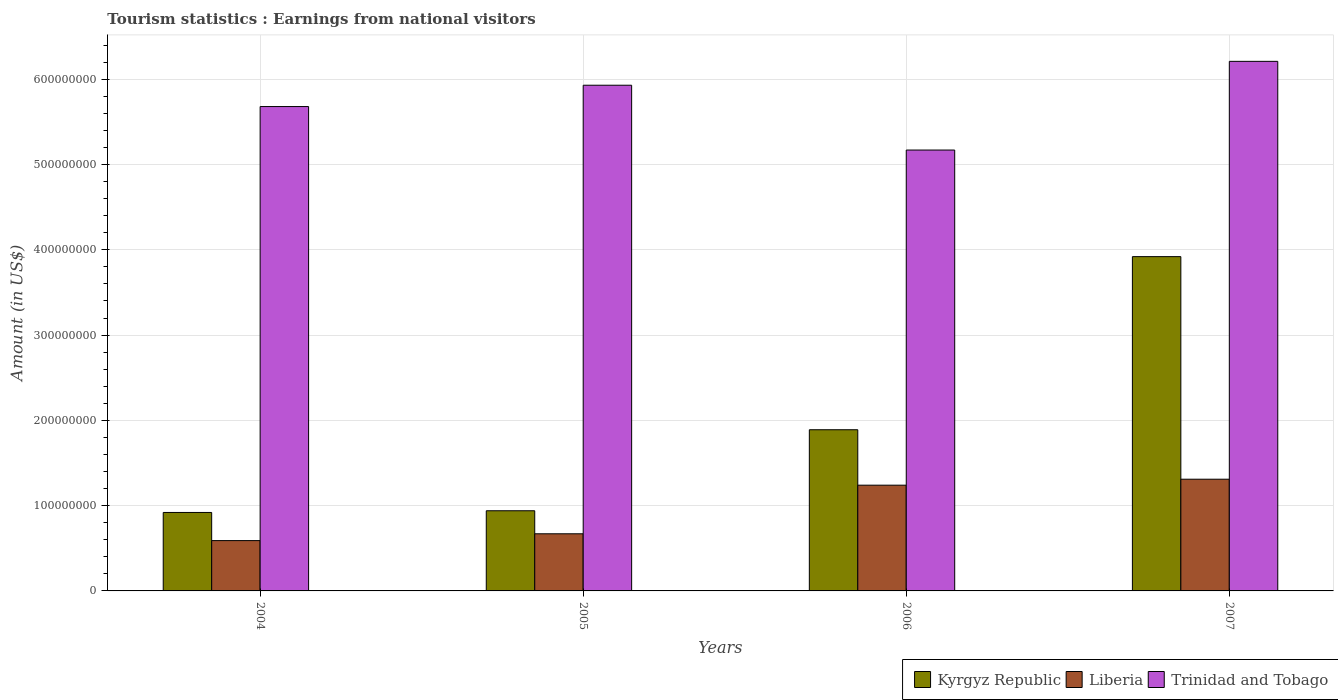How many different coloured bars are there?
Provide a short and direct response. 3. How many groups of bars are there?
Ensure brevity in your answer.  4. How many bars are there on the 4th tick from the left?
Provide a succinct answer. 3. What is the earnings from national visitors in Trinidad and Tobago in 2007?
Your response must be concise. 6.21e+08. Across all years, what is the maximum earnings from national visitors in Trinidad and Tobago?
Provide a succinct answer. 6.21e+08. Across all years, what is the minimum earnings from national visitors in Trinidad and Tobago?
Your answer should be compact. 5.17e+08. What is the total earnings from national visitors in Liberia in the graph?
Make the answer very short. 3.81e+08. What is the difference between the earnings from national visitors in Trinidad and Tobago in 2004 and that in 2007?
Your response must be concise. -5.30e+07. What is the difference between the earnings from national visitors in Kyrgyz Republic in 2007 and the earnings from national visitors in Trinidad and Tobago in 2005?
Provide a short and direct response. -2.01e+08. What is the average earnings from national visitors in Kyrgyz Republic per year?
Offer a very short reply. 1.92e+08. In the year 2005, what is the difference between the earnings from national visitors in Trinidad and Tobago and earnings from national visitors in Liberia?
Offer a terse response. 5.26e+08. In how many years, is the earnings from national visitors in Liberia greater than 420000000 US$?
Ensure brevity in your answer.  0. What is the ratio of the earnings from national visitors in Trinidad and Tobago in 2004 to that in 2007?
Offer a very short reply. 0.91. Is the earnings from national visitors in Liberia in 2004 less than that in 2006?
Keep it short and to the point. Yes. What is the difference between the highest and the second highest earnings from national visitors in Trinidad and Tobago?
Ensure brevity in your answer.  2.80e+07. What is the difference between the highest and the lowest earnings from national visitors in Trinidad and Tobago?
Ensure brevity in your answer.  1.04e+08. In how many years, is the earnings from national visitors in Kyrgyz Republic greater than the average earnings from national visitors in Kyrgyz Republic taken over all years?
Your answer should be compact. 1. What does the 2nd bar from the left in 2005 represents?
Offer a terse response. Liberia. What does the 3rd bar from the right in 2004 represents?
Offer a terse response. Kyrgyz Republic. Are all the bars in the graph horizontal?
Ensure brevity in your answer.  No. Are the values on the major ticks of Y-axis written in scientific E-notation?
Provide a succinct answer. No. Does the graph contain any zero values?
Provide a succinct answer. No. How many legend labels are there?
Offer a terse response. 3. How are the legend labels stacked?
Your response must be concise. Horizontal. What is the title of the graph?
Offer a very short reply. Tourism statistics : Earnings from national visitors. What is the label or title of the Y-axis?
Provide a short and direct response. Amount (in US$). What is the Amount (in US$) of Kyrgyz Republic in 2004?
Provide a succinct answer. 9.20e+07. What is the Amount (in US$) of Liberia in 2004?
Offer a very short reply. 5.90e+07. What is the Amount (in US$) of Trinidad and Tobago in 2004?
Make the answer very short. 5.68e+08. What is the Amount (in US$) of Kyrgyz Republic in 2005?
Give a very brief answer. 9.40e+07. What is the Amount (in US$) in Liberia in 2005?
Keep it short and to the point. 6.70e+07. What is the Amount (in US$) in Trinidad and Tobago in 2005?
Offer a terse response. 5.93e+08. What is the Amount (in US$) of Kyrgyz Republic in 2006?
Keep it short and to the point. 1.89e+08. What is the Amount (in US$) of Liberia in 2006?
Your response must be concise. 1.24e+08. What is the Amount (in US$) in Trinidad and Tobago in 2006?
Provide a succinct answer. 5.17e+08. What is the Amount (in US$) of Kyrgyz Republic in 2007?
Ensure brevity in your answer.  3.92e+08. What is the Amount (in US$) in Liberia in 2007?
Keep it short and to the point. 1.31e+08. What is the Amount (in US$) of Trinidad and Tobago in 2007?
Make the answer very short. 6.21e+08. Across all years, what is the maximum Amount (in US$) in Kyrgyz Republic?
Make the answer very short. 3.92e+08. Across all years, what is the maximum Amount (in US$) in Liberia?
Provide a succinct answer. 1.31e+08. Across all years, what is the maximum Amount (in US$) in Trinidad and Tobago?
Provide a short and direct response. 6.21e+08. Across all years, what is the minimum Amount (in US$) in Kyrgyz Republic?
Provide a short and direct response. 9.20e+07. Across all years, what is the minimum Amount (in US$) of Liberia?
Provide a short and direct response. 5.90e+07. Across all years, what is the minimum Amount (in US$) of Trinidad and Tobago?
Provide a short and direct response. 5.17e+08. What is the total Amount (in US$) in Kyrgyz Republic in the graph?
Offer a terse response. 7.67e+08. What is the total Amount (in US$) in Liberia in the graph?
Ensure brevity in your answer.  3.81e+08. What is the total Amount (in US$) of Trinidad and Tobago in the graph?
Your answer should be very brief. 2.30e+09. What is the difference between the Amount (in US$) of Liberia in 2004 and that in 2005?
Ensure brevity in your answer.  -8.00e+06. What is the difference between the Amount (in US$) in Trinidad and Tobago in 2004 and that in 2005?
Your answer should be very brief. -2.50e+07. What is the difference between the Amount (in US$) of Kyrgyz Republic in 2004 and that in 2006?
Make the answer very short. -9.70e+07. What is the difference between the Amount (in US$) of Liberia in 2004 and that in 2006?
Keep it short and to the point. -6.50e+07. What is the difference between the Amount (in US$) in Trinidad and Tobago in 2004 and that in 2006?
Provide a short and direct response. 5.10e+07. What is the difference between the Amount (in US$) in Kyrgyz Republic in 2004 and that in 2007?
Give a very brief answer. -3.00e+08. What is the difference between the Amount (in US$) of Liberia in 2004 and that in 2007?
Make the answer very short. -7.20e+07. What is the difference between the Amount (in US$) of Trinidad and Tobago in 2004 and that in 2007?
Give a very brief answer. -5.30e+07. What is the difference between the Amount (in US$) in Kyrgyz Republic in 2005 and that in 2006?
Offer a terse response. -9.50e+07. What is the difference between the Amount (in US$) in Liberia in 2005 and that in 2006?
Your answer should be compact. -5.70e+07. What is the difference between the Amount (in US$) in Trinidad and Tobago in 2005 and that in 2006?
Offer a terse response. 7.60e+07. What is the difference between the Amount (in US$) of Kyrgyz Republic in 2005 and that in 2007?
Ensure brevity in your answer.  -2.98e+08. What is the difference between the Amount (in US$) in Liberia in 2005 and that in 2007?
Provide a succinct answer. -6.40e+07. What is the difference between the Amount (in US$) of Trinidad and Tobago in 2005 and that in 2007?
Make the answer very short. -2.80e+07. What is the difference between the Amount (in US$) of Kyrgyz Republic in 2006 and that in 2007?
Provide a succinct answer. -2.03e+08. What is the difference between the Amount (in US$) of Liberia in 2006 and that in 2007?
Give a very brief answer. -7.00e+06. What is the difference between the Amount (in US$) in Trinidad and Tobago in 2006 and that in 2007?
Make the answer very short. -1.04e+08. What is the difference between the Amount (in US$) in Kyrgyz Republic in 2004 and the Amount (in US$) in Liberia in 2005?
Your response must be concise. 2.50e+07. What is the difference between the Amount (in US$) in Kyrgyz Republic in 2004 and the Amount (in US$) in Trinidad and Tobago in 2005?
Your response must be concise. -5.01e+08. What is the difference between the Amount (in US$) in Liberia in 2004 and the Amount (in US$) in Trinidad and Tobago in 2005?
Provide a short and direct response. -5.34e+08. What is the difference between the Amount (in US$) of Kyrgyz Republic in 2004 and the Amount (in US$) of Liberia in 2006?
Your answer should be very brief. -3.20e+07. What is the difference between the Amount (in US$) of Kyrgyz Republic in 2004 and the Amount (in US$) of Trinidad and Tobago in 2006?
Make the answer very short. -4.25e+08. What is the difference between the Amount (in US$) in Liberia in 2004 and the Amount (in US$) in Trinidad and Tobago in 2006?
Your answer should be very brief. -4.58e+08. What is the difference between the Amount (in US$) in Kyrgyz Republic in 2004 and the Amount (in US$) in Liberia in 2007?
Keep it short and to the point. -3.90e+07. What is the difference between the Amount (in US$) in Kyrgyz Republic in 2004 and the Amount (in US$) in Trinidad and Tobago in 2007?
Your answer should be compact. -5.29e+08. What is the difference between the Amount (in US$) of Liberia in 2004 and the Amount (in US$) of Trinidad and Tobago in 2007?
Your answer should be very brief. -5.62e+08. What is the difference between the Amount (in US$) of Kyrgyz Republic in 2005 and the Amount (in US$) of Liberia in 2006?
Give a very brief answer. -3.00e+07. What is the difference between the Amount (in US$) of Kyrgyz Republic in 2005 and the Amount (in US$) of Trinidad and Tobago in 2006?
Offer a terse response. -4.23e+08. What is the difference between the Amount (in US$) in Liberia in 2005 and the Amount (in US$) in Trinidad and Tobago in 2006?
Offer a terse response. -4.50e+08. What is the difference between the Amount (in US$) in Kyrgyz Republic in 2005 and the Amount (in US$) in Liberia in 2007?
Ensure brevity in your answer.  -3.70e+07. What is the difference between the Amount (in US$) of Kyrgyz Republic in 2005 and the Amount (in US$) of Trinidad and Tobago in 2007?
Your response must be concise. -5.27e+08. What is the difference between the Amount (in US$) of Liberia in 2005 and the Amount (in US$) of Trinidad and Tobago in 2007?
Provide a short and direct response. -5.54e+08. What is the difference between the Amount (in US$) in Kyrgyz Republic in 2006 and the Amount (in US$) in Liberia in 2007?
Ensure brevity in your answer.  5.80e+07. What is the difference between the Amount (in US$) of Kyrgyz Republic in 2006 and the Amount (in US$) of Trinidad and Tobago in 2007?
Give a very brief answer. -4.32e+08. What is the difference between the Amount (in US$) in Liberia in 2006 and the Amount (in US$) in Trinidad and Tobago in 2007?
Give a very brief answer. -4.97e+08. What is the average Amount (in US$) in Kyrgyz Republic per year?
Offer a very short reply. 1.92e+08. What is the average Amount (in US$) in Liberia per year?
Your answer should be very brief. 9.52e+07. What is the average Amount (in US$) of Trinidad and Tobago per year?
Give a very brief answer. 5.75e+08. In the year 2004, what is the difference between the Amount (in US$) in Kyrgyz Republic and Amount (in US$) in Liberia?
Your answer should be compact. 3.30e+07. In the year 2004, what is the difference between the Amount (in US$) of Kyrgyz Republic and Amount (in US$) of Trinidad and Tobago?
Ensure brevity in your answer.  -4.76e+08. In the year 2004, what is the difference between the Amount (in US$) of Liberia and Amount (in US$) of Trinidad and Tobago?
Make the answer very short. -5.09e+08. In the year 2005, what is the difference between the Amount (in US$) of Kyrgyz Republic and Amount (in US$) of Liberia?
Ensure brevity in your answer.  2.70e+07. In the year 2005, what is the difference between the Amount (in US$) of Kyrgyz Republic and Amount (in US$) of Trinidad and Tobago?
Your answer should be compact. -4.99e+08. In the year 2005, what is the difference between the Amount (in US$) of Liberia and Amount (in US$) of Trinidad and Tobago?
Your response must be concise. -5.26e+08. In the year 2006, what is the difference between the Amount (in US$) of Kyrgyz Republic and Amount (in US$) of Liberia?
Your answer should be compact. 6.50e+07. In the year 2006, what is the difference between the Amount (in US$) in Kyrgyz Republic and Amount (in US$) in Trinidad and Tobago?
Offer a very short reply. -3.28e+08. In the year 2006, what is the difference between the Amount (in US$) in Liberia and Amount (in US$) in Trinidad and Tobago?
Offer a terse response. -3.93e+08. In the year 2007, what is the difference between the Amount (in US$) of Kyrgyz Republic and Amount (in US$) of Liberia?
Keep it short and to the point. 2.61e+08. In the year 2007, what is the difference between the Amount (in US$) of Kyrgyz Republic and Amount (in US$) of Trinidad and Tobago?
Give a very brief answer. -2.29e+08. In the year 2007, what is the difference between the Amount (in US$) of Liberia and Amount (in US$) of Trinidad and Tobago?
Your answer should be compact. -4.90e+08. What is the ratio of the Amount (in US$) of Kyrgyz Republic in 2004 to that in 2005?
Ensure brevity in your answer.  0.98. What is the ratio of the Amount (in US$) in Liberia in 2004 to that in 2005?
Your response must be concise. 0.88. What is the ratio of the Amount (in US$) of Trinidad and Tobago in 2004 to that in 2005?
Provide a succinct answer. 0.96. What is the ratio of the Amount (in US$) in Kyrgyz Republic in 2004 to that in 2006?
Provide a succinct answer. 0.49. What is the ratio of the Amount (in US$) in Liberia in 2004 to that in 2006?
Ensure brevity in your answer.  0.48. What is the ratio of the Amount (in US$) in Trinidad and Tobago in 2004 to that in 2006?
Keep it short and to the point. 1.1. What is the ratio of the Amount (in US$) of Kyrgyz Republic in 2004 to that in 2007?
Keep it short and to the point. 0.23. What is the ratio of the Amount (in US$) of Liberia in 2004 to that in 2007?
Make the answer very short. 0.45. What is the ratio of the Amount (in US$) of Trinidad and Tobago in 2004 to that in 2007?
Your answer should be very brief. 0.91. What is the ratio of the Amount (in US$) of Kyrgyz Republic in 2005 to that in 2006?
Ensure brevity in your answer.  0.5. What is the ratio of the Amount (in US$) of Liberia in 2005 to that in 2006?
Your answer should be compact. 0.54. What is the ratio of the Amount (in US$) in Trinidad and Tobago in 2005 to that in 2006?
Offer a very short reply. 1.15. What is the ratio of the Amount (in US$) of Kyrgyz Republic in 2005 to that in 2007?
Ensure brevity in your answer.  0.24. What is the ratio of the Amount (in US$) of Liberia in 2005 to that in 2007?
Provide a succinct answer. 0.51. What is the ratio of the Amount (in US$) in Trinidad and Tobago in 2005 to that in 2007?
Provide a short and direct response. 0.95. What is the ratio of the Amount (in US$) of Kyrgyz Republic in 2006 to that in 2007?
Provide a short and direct response. 0.48. What is the ratio of the Amount (in US$) of Liberia in 2006 to that in 2007?
Your response must be concise. 0.95. What is the ratio of the Amount (in US$) in Trinidad and Tobago in 2006 to that in 2007?
Your response must be concise. 0.83. What is the difference between the highest and the second highest Amount (in US$) of Kyrgyz Republic?
Offer a terse response. 2.03e+08. What is the difference between the highest and the second highest Amount (in US$) of Liberia?
Give a very brief answer. 7.00e+06. What is the difference between the highest and the second highest Amount (in US$) in Trinidad and Tobago?
Give a very brief answer. 2.80e+07. What is the difference between the highest and the lowest Amount (in US$) in Kyrgyz Republic?
Your answer should be very brief. 3.00e+08. What is the difference between the highest and the lowest Amount (in US$) of Liberia?
Give a very brief answer. 7.20e+07. What is the difference between the highest and the lowest Amount (in US$) of Trinidad and Tobago?
Make the answer very short. 1.04e+08. 